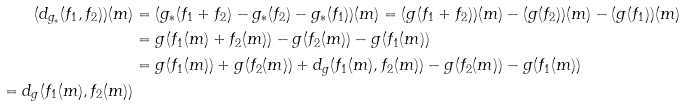Convert formula to latex. <formula><loc_0><loc_0><loc_500><loc_500>( d _ { g _ { * } } ( f _ { 1 } , f _ { 2 } ) ) ( m ) & = ( g _ { * } ( f _ { 1 } + f _ { 2 } ) - g _ { * } ( f _ { 2 } ) - g _ { * } ( f _ { 1 } ) ) ( m ) = ( g ( f _ { 1 } + f _ { 2 } ) ) ( m ) - ( g ( f _ { 2 } ) ) ( m ) - ( g ( f _ { 1 } ) ) ( m ) \\ & = g ( f _ { 1 } ( m ) + f _ { 2 } ( m ) ) - g ( f _ { 2 } ( m ) ) - g ( f _ { 1 } ( m ) ) \\ & = g ( f _ { 1 } ( m ) ) + g ( f _ { 2 } ( m ) ) + d _ { g } ( f _ { 1 } ( m ) , f _ { 2 } ( m ) ) - g ( f _ { 2 } ( m ) ) - g ( f _ { 1 } ( m ) ) \\ = d _ { g } ( f _ { 1 } ( m ) , f _ { 2 } ( m ) )</formula> 